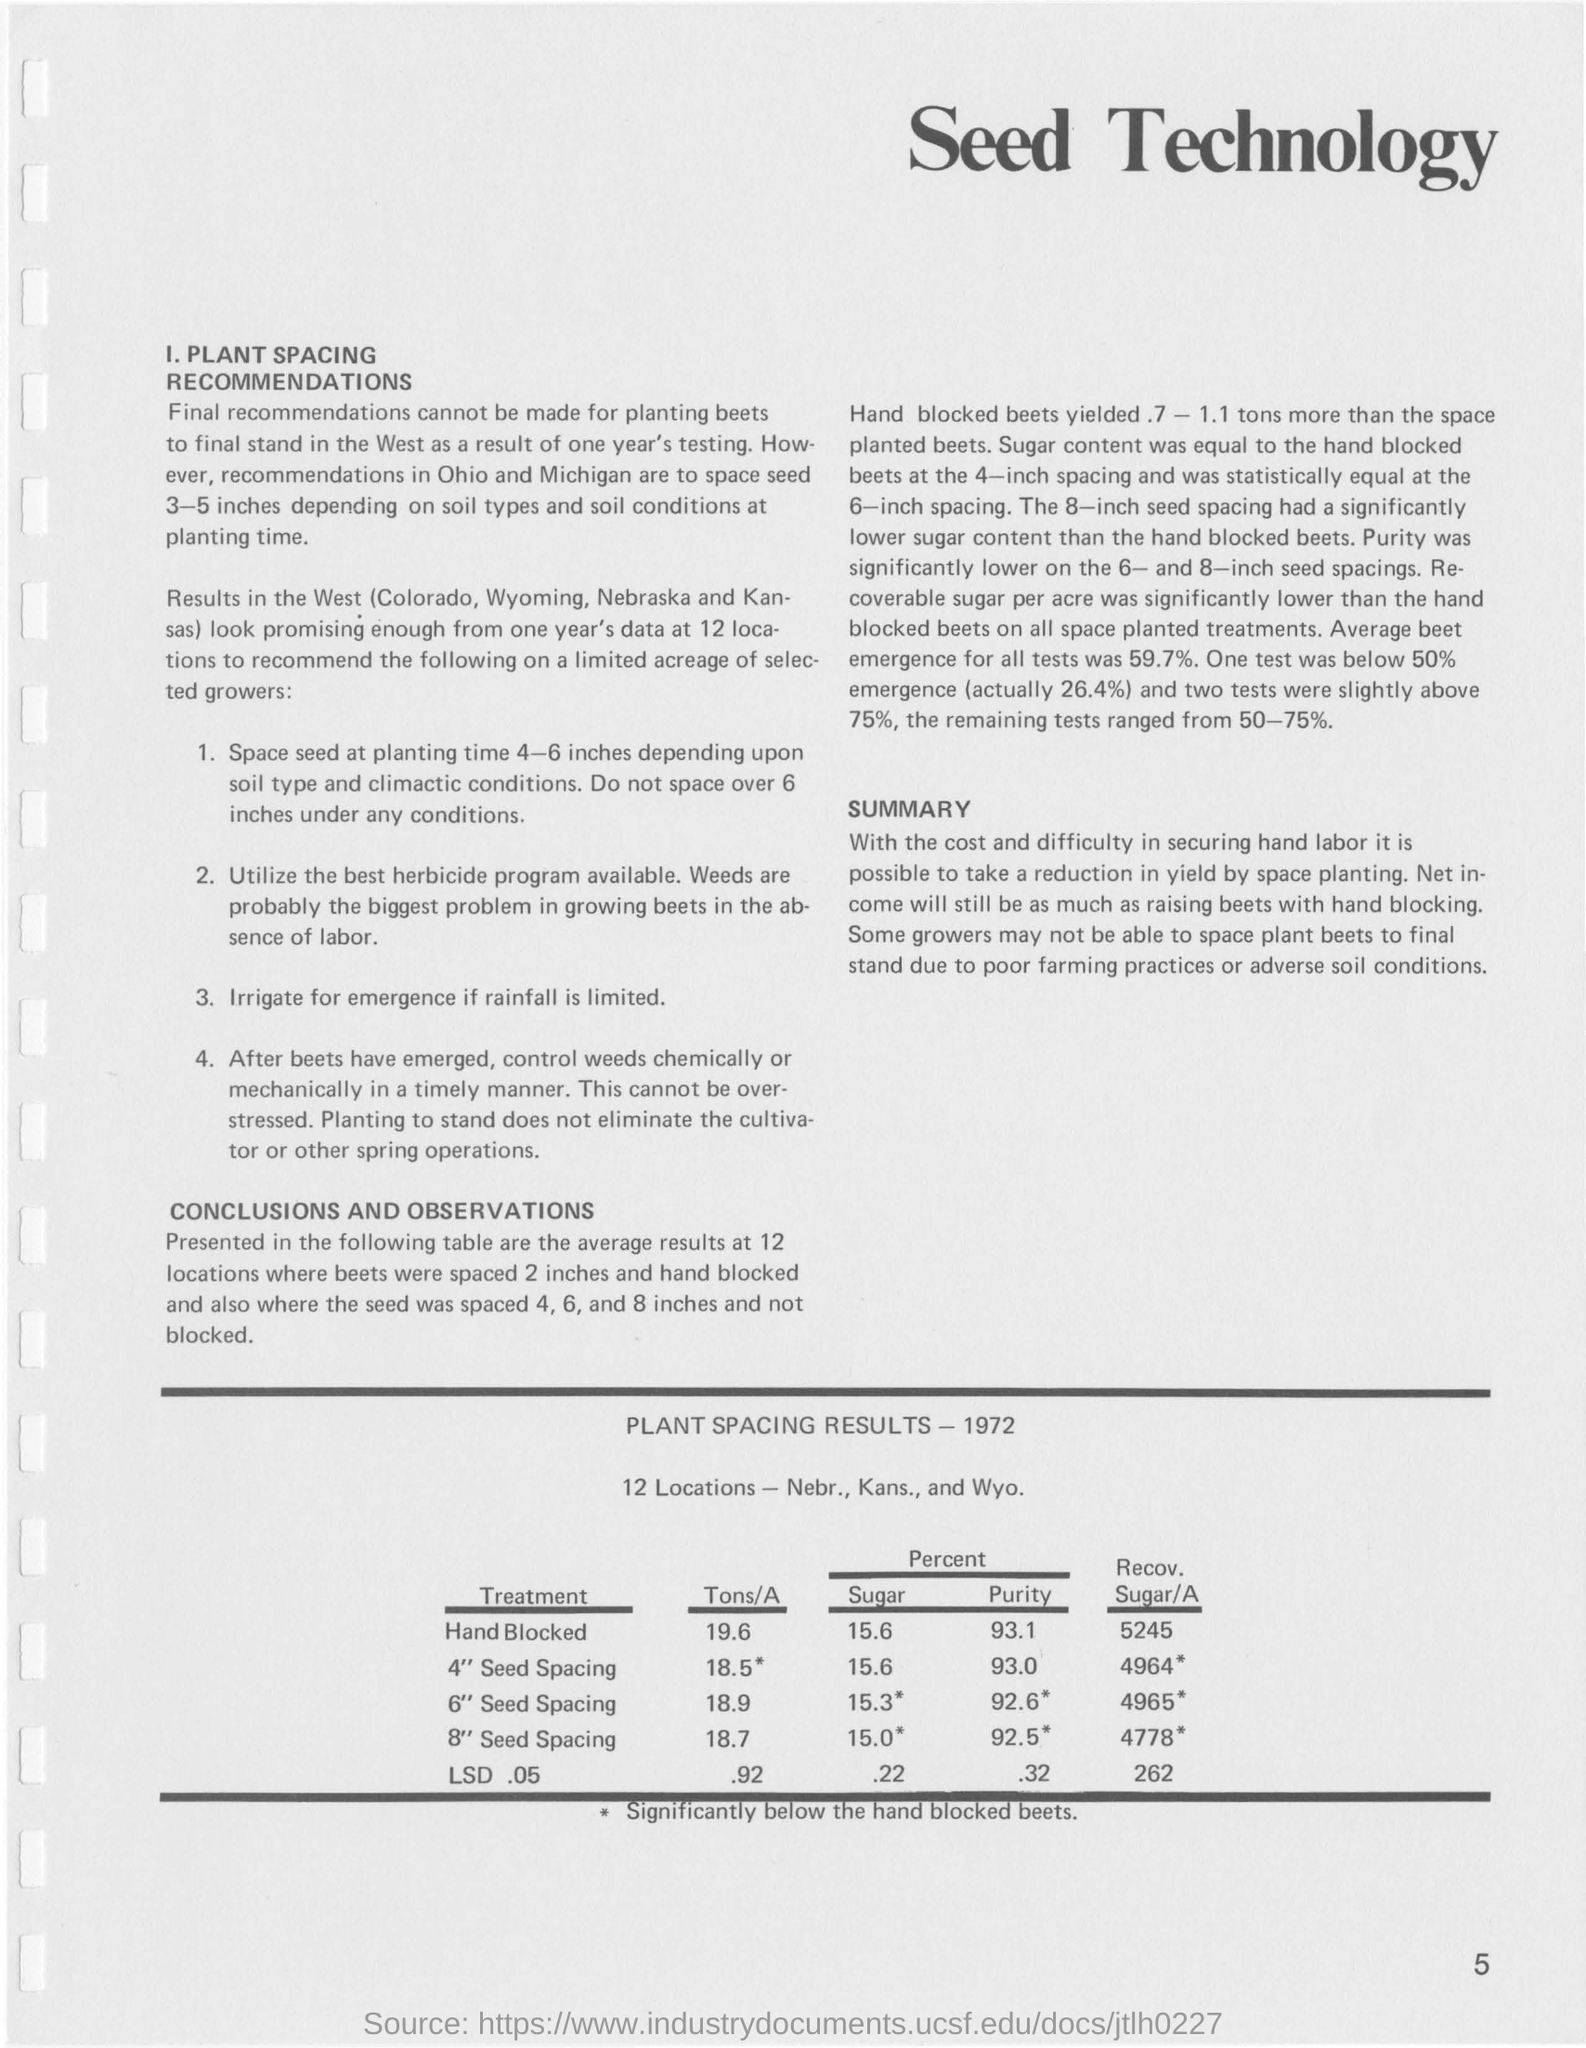Mention a couple of crucial points in this snapshot. The places in the West where results are seen are Colorado, Wyoming, Nebraska, and Kansas. 